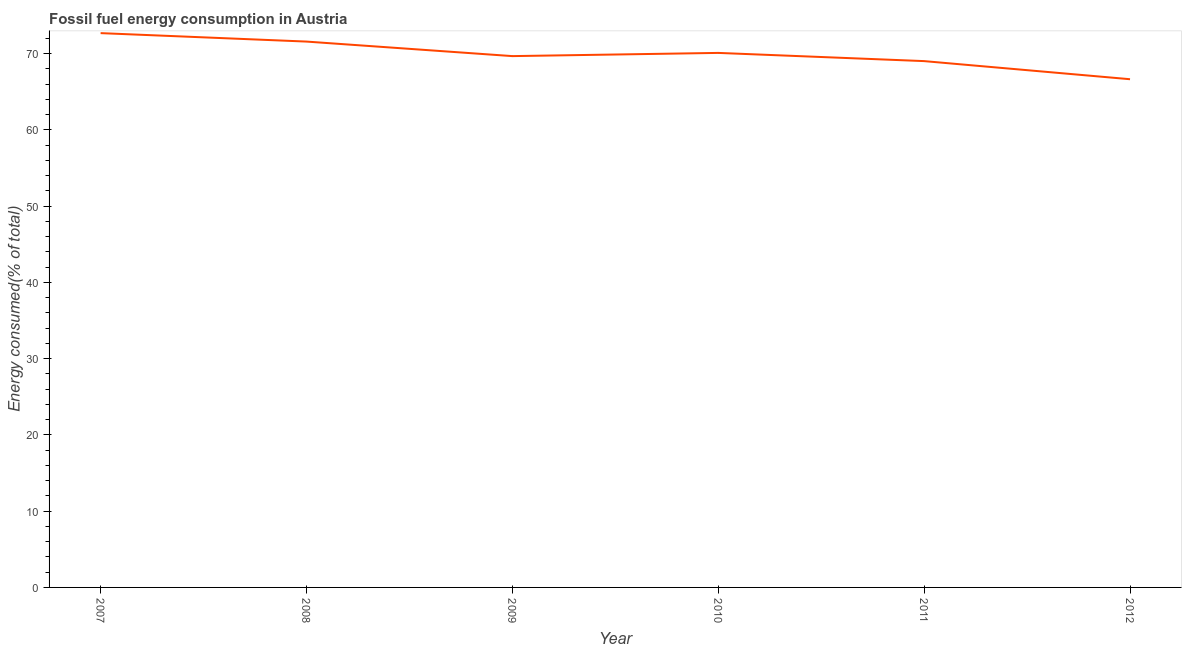What is the fossil fuel energy consumption in 2010?
Keep it short and to the point. 70.11. Across all years, what is the maximum fossil fuel energy consumption?
Make the answer very short. 72.7. Across all years, what is the minimum fossil fuel energy consumption?
Keep it short and to the point. 66.66. In which year was the fossil fuel energy consumption minimum?
Keep it short and to the point. 2012. What is the sum of the fossil fuel energy consumption?
Provide a short and direct response. 419.78. What is the difference between the fossil fuel energy consumption in 2008 and 2012?
Make the answer very short. 4.94. What is the average fossil fuel energy consumption per year?
Keep it short and to the point. 69.96. What is the median fossil fuel energy consumption?
Offer a terse response. 69.9. Do a majority of the years between 2010 and 2007 (inclusive) have fossil fuel energy consumption greater than 32 %?
Offer a very short reply. Yes. What is the ratio of the fossil fuel energy consumption in 2007 to that in 2010?
Offer a very short reply. 1.04. What is the difference between the highest and the second highest fossil fuel energy consumption?
Give a very brief answer. 1.11. What is the difference between the highest and the lowest fossil fuel energy consumption?
Your answer should be very brief. 6.04. Does the fossil fuel energy consumption monotonically increase over the years?
Provide a short and direct response. No. How many lines are there?
Make the answer very short. 1. How many years are there in the graph?
Your answer should be very brief. 6. What is the difference between two consecutive major ticks on the Y-axis?
Offer a terse response. 10. Are the values on the major ticks of Y-axis written in scientific E-notation?
Give a very brief answer. No. Does the graph contain any zero values?
Make the answer very short. No. Does the graph contain grids?
Your answer should be compact. No. What is the title of the graph?
Keep it short and to the point. Fossil fuel energy consumption in Austria. What is the label or title of the X-axis?
Provide a short and direct response. Year. What is the label or title of the Y-axis?
Your answer should be very brief. Energy consumed(% of total). What is the Energy consumed(% of total) in 2007?
Offer a very short reply. 72.7. What is the Energy consumed(% of total) of 2008?
Offer a very short reply. 71.59. What is the Energy consumed(% of total) in 2009?
Offer a terse response. 69.69. What is the Energy consumed(% of total) of 2010?
Make the answer very short. 70.11. What is the Energy consumed(% of total) of 2011?
Provide a succinct answer. 69.03. What is the Energy consumed(% of total) in 2012?
Give a very brief answer. 66.66. What is the difference between the Energy consumed(% of total) in 2007 and 2008?
Make the answer very short. 1.11. What is the difference between the Energy consumed(% of total) in 2007 and 2009?
Your response must be concise. 3.01. What is the difference between the Energy consumed(% of total) in 2007 and 2010?
Your response must be concise. 2.59. What is the difference between the Energy consumed(% of total) in 2007 and 2011?
Give a very brief answer. 3.67. What is the difference between the Energy consumed(% of total) in 2007 and 2012?
Make the answer very short. 6.04. What is the difference between the Energy consumed(% of total) in 2008 and 2009?
Your response must be concise. 1.91. What is the difference between the Energy consumed(% of total) in 2008 and 2010?
Ensure brevity in your answer.  1.49. What is the difference between the Energy consumed(% of total) in 2008 and 2011?
Offer a very short reply. 2.56. What is the difference between the Energy consumed(% of total) in 2008 and 2012?
Your answer should be very brief. 4.94. What is the difference between the Energy consumed(% of total) in 2009 and 2010?
Make the answer very short. -0.42. What is the difference between the Energy consumed(% of total) in 2009 and 2011?
Make the answer very short. 0.66. What is the difference between the Energy consumed(% of total) in 2009 and 2012?
Your answer should be very brief. 3.03. What is the difference between the Energy consumed(% of total) in 2010 and 2011?
Provide a succinct answer. 1.08. What is the difference between the Energy consumed(% of total) in 2010 and 2012?
Provide a short and direct response. 3.45. What is the difference between the Energy consumed(% of total) in 2011 and 2012?
Keep it short and to the point. 2.37. What is the ratio of the Energy consumed(% of total) in 2007 to that in 2009?
Give a very brief answer. 1.04. What is the ratio of the Energy consumed(% of total) in 2007 to that in 2011?
Keep it short and to the point. 1.05. What is the ratio of the Energy consumed(% of total) in 2007 to that in 2012?
Provide a succinct answer. 1.09. What is the ratio of the Energy consumed(% of total) in 2008 to that in 2012?
Your answer should be very brief. 1.07. What is the ratio of the Energy consumed(% of total) in 2009 to that in 2012?
Your answer should be very brief. 1.04. What is the ratio of the Energy consumed(% of total) in 2010 to that in 2011?
Provide a short and direct response. 1.02. What is the ratio of the Energy consumed(% of total) in 2010 to that in 2012?
Make the answer very short. 1.05. What is the ratio of the Energy consumed(% of total) in 2011 to that in 2012?
Give a very brief answer. 1.04. 